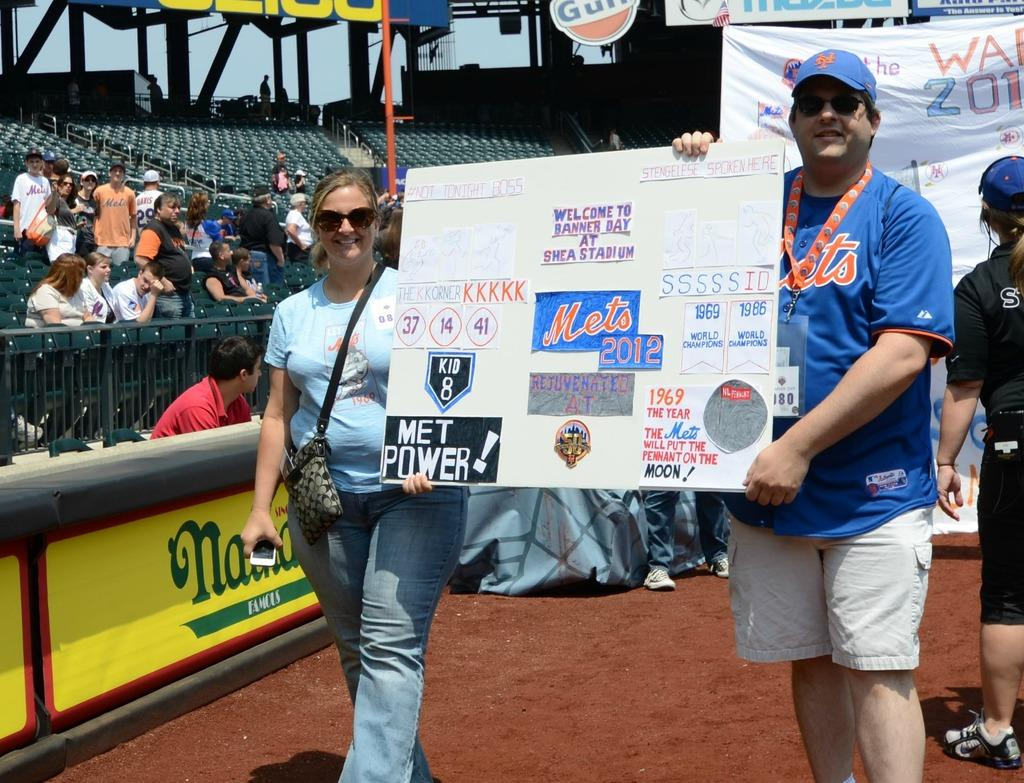<image>
Describe the image concisely. woman and man hold up a poster for the Mets. 